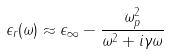Convert formula to latex. <formula><loc_0><loc_0><loc_500><loc_500>\epsilon _ { r } ( \omega ) \approx \epsilon _ { \infty } - \frac { \omega _ { p } ^ { 2 } } { \omega ^ { 2 } + i \gamma \omega }</formula> 